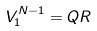<formula> <loc_0><loc_0><loc_500><loc_500>V _ { 1 } ^ { N - 1 } = Q R</formula> 